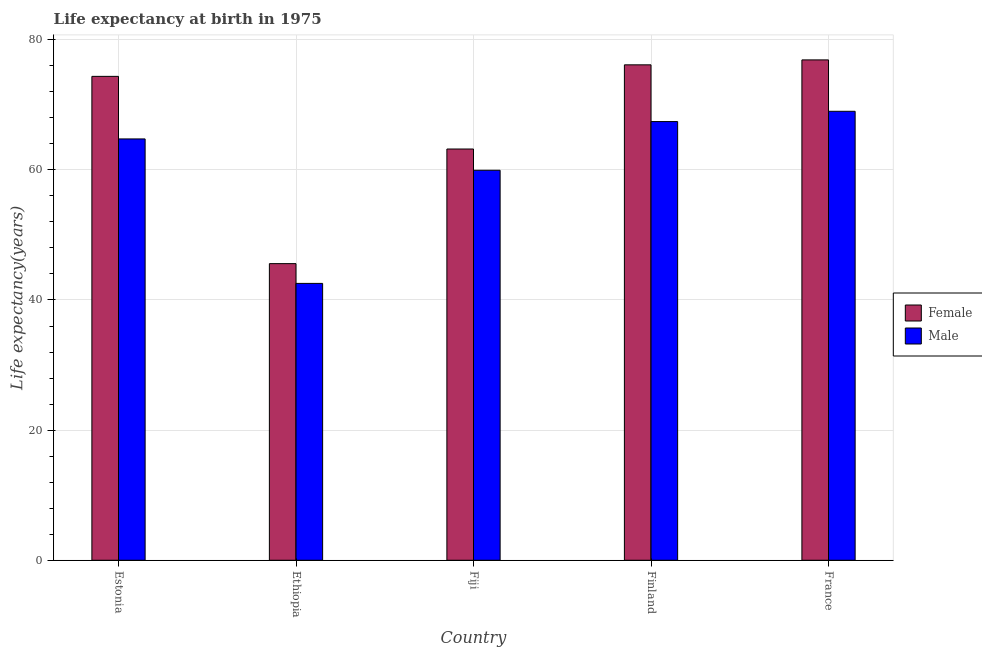How many groups of bars are there?
Ensure brevity in your answer.  5. How many bars are there on the 1st tick from the right?
Offer a very short reply. 2. In how many cases, is the number of bars for a given country not equal to the number of legend labels?
Your answer should be compact. 0. What is the life expectancy(female) in Fiji?
Provide a succinct answer. 63.2. Across all countries, what is the maximum life expectancy(female)?
Keep it short and to the point. 76.9. Across all countries, what is the minimum life expectancy(female)?
Provide a short and direct response. 45.59. In which country was the life expectancy(female) maximum?
Provide a succinct answer. France. In which country was the life expectancy(male) minimum?
Your answer should be very brief. Ethiopia. What is the total life expectancy(female) in the graph?
Your response must be concise. 336.2. What is the difference between the life expectancy(female) in Ethiopia and that in Finland?
Provide a short and direct response. -30.55. What is the difference between the life expectancy(male) in Finland and the life expectancy(female) in Ethiopia?
Provide a short and direct response. 21.83. What is the average life expectancy(male) per country?
Provide a short and direct response. 60.73. What is the difference between the life expectancy(male) and life expectancy(female) in Estonia?
Give a very brief answer. -9.61. In how many countries, is the life expectancy(male) greater than 44 years?
Your response must be concise. 4. What is the ratio of the life expectancy(female) in Finland to that in France?
Provide a succinct answer. 0.99. Is the life expectancy(male) in Estonia less than that in Ethiopia?
Offer a very short reply. No. What is the difference between the highest and the second highest life expectancy(male)?
Provide a short and direct response. 1.58. What is the difference between the highest and the lowest life expectancy(male)?
Your answer should be compact. 26.45. In how many countries, is the life expectancy(male) greater than the average life expectancy(male) taken over all countries?
Offer a terse response. 3. What does the 2nd bar from the left in France represents?
Your answer should be compact. Male. What does the 2nd bar from the right in Ethiopia represents?
Ensure brevity in your answer.  Female. How many bars are there?
Provide a succinct answer. 10. Are all the bars in the graph horizontal?
Keep it short and to the point. No. How many countries are there in the graph?
Offer a very short reply. 5. Does the graph contain grids?
Ensure brevity in your answer.  Yes. How are the legend labels stacked?
Provide a short and direct response. Vertical. What is the title of the graph?
Give a very brief answer. Life expectancy at birth in 1975. Does "Under five" appear as one of the legend labels in the graph?
Provide a succinct answer. No. What is the label or title of the Y-axis?
Give a very brief answer. Life expectancy(years). What is the Life expectancy(years) of Female in Estonia?
Your answer should be compact. 74.37. What is the Life expectancy(years) of Male in Estonia?
Give a very brief answer. 64.75. What is the Life expectancy(years) of Female in Ethiopia?
Your answer should be very brief. 45.59. What is the Life expectancy(years) of Male in Ethiopia?
Provide a short and direct response. 42.55. What is the Life expectancy(years) in Female in Fiji?
Offer a terse response. 63.2. What is the Life expectancy(years) of Male in Fiji?
Your answer should be compact. 59.94. What is the Life expectancy(years) of Female in Finland?
Give a very brief answer. 76.14. What is the Life expectancy(years) of Male in Finland?
Your response must be concise. 67.42. What is the Life expectancy(years) of Female in France?
Your response must be concise. 76.9. What is the Life expectancy(years) in Male in France?
Offer a very short reply. 69. Across all countries, what is the maximum Life expectancy(years) in Female?
Ensure brevity in your answer.  76.9. Across all countries, what is the maximum Life expectancy(years) in Male?
Ensure brevity in your answer.  69. Across all countries, what is the minimum Life expectancy(years) in Female?
Make the answer very short. 45.59. Across all countries, what is the minimum Life expectancy(years) of Male?
Give a very brief answer. 42.55. What is the total Life expectancy(years) of Female in the graph?
Provide a short and direct response. 336.2. What is the total Life expectancy(years) of Male in the graph?
Make the answer very short. 303.66. What is the difference between the Life expectancy(years) of Female in Estonia and that in Ethiopia?
Offer a terse response. 28.78. What is the difference between the Life expectancy(years) in Male in Estonia and that in Ethiopia?
Keep it short and to the point. 22.2. What is the difference between the Life expectancy(years) of Female in Estonia and that in Fiji?
Provide a succinct answer. 11.16. What is the difference between the Life expectancy(years) in Male in Estonia and that in Fiji?
Offer a very short reply. 4.82. What is the difference between the Life expectancy(years) in Female in Estonia and that in Finland?
Your answer should be compact. -1.77. What is the difference between the Life expectancy(years) in Male in Estonia and that in Finland?
Offer a very short reply. -2.67. What is the difference between the Life expectancy(years) in Female in Estonia and that in France?
Keep it short and to the point. -2.53. What is the difference between the Life expectancy(years) in Male in Estonia and that in France?
Your answer should be compact. -4.25. What is the difference between the Life expectancy(years) in Female in Ethiopia and that in Fiji?
Make the answer very short. -17.62. What is the difference between the Life expectancy(years) of Male in Ethiopia and that in Fiji?
Offer a terse response. -17.39. What is the difference between the Life expectancy(years) of Female in Ethiopia and that in Finland?
Your answer should be compact. -30.55. What is the difference between the Life expectancy(years) of Male in Ethiopia and that in Finland?
Make the answer very short. -24.87. What is the difference between the Life expectancy(years) in Female in Ethiopia and that in France?
Make the answer very short. -31.31. What is the difference between the Life expectancy(years) in Male in Ethiopia and that in France?
Provide a short and direct response. -26.45. What is the difference between the Life expectancy(years) of Female in Fiji and that in Finland?
Provide a succinct answer. -12.94. What is the difference between the Life expectancy(years) of Male in Fiji and that in Finland?
Your answer should be compact. -7.48. What is the difference between the Life expectancy(years) of Female in Fiji and that in France?
Keep it short and to the point. -13.7. What is the difference between the Life expectancy(years) of Male in Fiji and that in France?
Offer a terse response. -9.06. What is the difference between the Life expectancy(years) in Female in Finland and that in France?
Provide a succinct answer. -0.76. What is the difference between the Life expectancy(years) of Male in Finland and that in France?
Provide a succinct answer. -1.58. What is the difference between the Life expectancy(years) of Female in Estonia and the Life expectancy(years) of Male in Ethiopia?
Give a very brief answer. 31.82. What is the difference between the Life expectancy(years) of Female in Estonia and the Life expectancy(years) of Male in Fiji?
Your answer should be compact. 14.43. What is the difference between the Life expectancy(years) of Female in Estonia and the Life expectancy(years) of Male in Finland?
Give a very brief answer. 6.95. What is the difference between the Life expectancy(years) in Female in Estonia and the Life expectancy(years) in Male in France?
Provide a succinct answer. 5.37. What is the difference between the Life expectancy(years) in Female in Ethiopia and the Life expectancy(years) in Male in Fiji?
Provide a succinct answer. -14.35. What is the difference between the Life expectancy(years) of Female in Ethiopia and the Life expectancy(years) of Male in Finland?
Make the answer very short. -21.83. What is the difference between the Life expectancy(years) in Female in Ethiopia and the Life expectancy(years) in Male in France?
Your response must be concise. -23.41. What is the difference between the Life expectancy(years) in Female in Fiji and the Life expectancy(years) in Male in Finland?
Give a very brief answer. -4.21. What is the difference between the Life expectancy(years) in Female in Fiji and the Life expectancy(years) in Male in France?
Provide a short and direct response. -5.79. What is the difference between the Life expectancy(years) of Female in Finland and the Life expectancy(years) of Male in France?
Provide a short and direct response. 7.14. What is the average Life expectancy(years) in Female per country?
Provide a short and direct response. 67.24. What is the average Life expectancy(years) of Male per country?
Your answer should be very brief. 60.73. What is the difference between the Life expectancy(years) in Female and Life expectancy(years) in Male in Estonia?
Your response must be concise. 9.61. What is the difference between the Life expectancy(years) in Female and Life expectancy(years) in Male in Ethiopia?
Your response must be concise. 3.04. What is the difference between the Life expectancy(years) of Female and Life expectancy(years) of Male in Fiji?
Your answer should be compact. 3.27. What is the difference between the Life expectancy(years) of Female and Life expectancy(years) of Male in Finland?
Your answer should be compact. 8.72. What is the difference between the Life expectancy(years) of Female and Life expectancy(years) of Male in France?
Ensure brevity in your answer.  7.9. What is the ratio of the Life expectancy(years) in Female in Estonia to that in Ethiopia?
Provide a short and direct response. 1.63. What is the ratio of the Life expectancy(years) of Male in Estonia to that in Ethiopia?
Your answer should be very brief. 1.52. What is the ratio of the Life expectancy(years) of Female in Estonia to that in Fiji?
Provide a short and direct response. 1.18. What is the ratio of the Life expectancy(years) in Male in Estonia to that in Fiji?
Make the answer very short. 1.08. What is the ratio of the Life expectancy(years) of Female in Estonia to that in Finland?
Your answer should be very brief. 0.98. What is the ratio of the Life expectancy(years) in Male in Estonia to that in Finland?
Your answer should be very brief. 0.96. What is the ratio of the Life expectancy(years) in Female in Estonia to that in France?
Keep it short and to the point. 0.97. What is the ratio of the Life expectancy(years) in Male in Estonia to that in France?
Keep it short and to the point. 0.94. What is the ratio of the Life expectancy(years) of Female in Ethiopia to that in Fiji?
Ensure brevity in your answer.  0.72. What is the ratio of the Life expectancy(years) of Male in Ethiopia to that in Fiji?
Keep it short and to the point. 0.71. What is the ratio of the Life expectancy(years) of Female in Ethiopia to that in Finland?
Your response must be concise. 0.6. What is the ratio of the Life expectancy(years) of Male in Ethiopia to that in Finland?
Provide a succinct answer. 0.63. What is the ratio of the Life expectancy(years) of Female in Ethiopia to that in France?
Provide a succinct answer. 0.59. What is the ratio of the Life expectancy(years) in Male in Ethiopia to that in France?
Your answer should be very brief. 0.62. What is the ratio of the Life expectancy(years) in Female in Fiji to that in Finland?
Give a very brief answer. 0.83. What is the ratio of the Life expectancy(years) in Male in Fiji to that in Finland?
Provide a succinct answer. 0.89. What is the ratio of the Life expectancy(years) of Female in Fiji to that in France?
Give a very brief answer. 0.82. What is the ratio of the Life expectancy(years) in Male in Fiji to that in France?
Your answer should be very brief. 0.87. What is the ratio of the Life expectancy(years) of Female in Finland to that in France?
Provide a succinct answer. 0.99. What is the ratio of the Life expectancy(years) of Male in Finland to that in France?
Offer a very short reply. 0.98. What is the difference between the highest and the second highest Life expectancy(years) in Female?
Keep it short and to the point. 0.76. What is the difference between the highest and the second highest Life expectancy(years) in Male?
Your answer should be very brief. 1.58. What is the difference between the highest and the lowest Life expectancy(years) in Female?
Your answer should be very brief. 31.31. What is the difference between the highest and the lowest Life expectancy(years) in Male?
Make the answer very short. 26.45. 